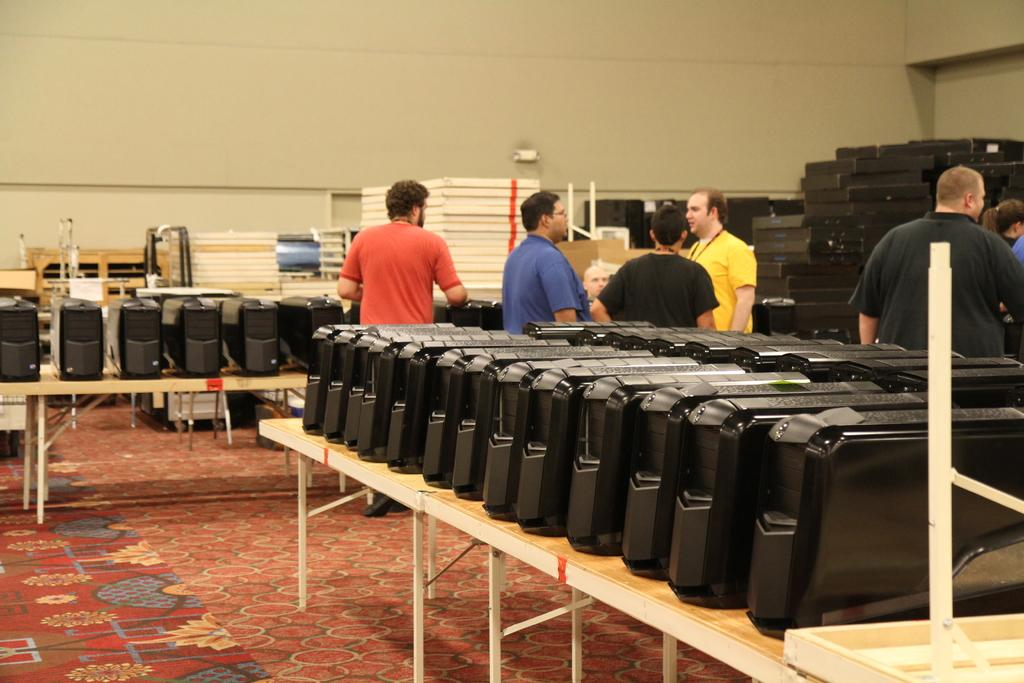What type of electronic components are on the table in the image? There are CPUs on the table in the image. What are the people doing in the image? The people are standing behind the table and talking to each other. What type of railway system is visible in the image? There is no railway system present in the image; it features CPUs on a table and people standing behind it. 